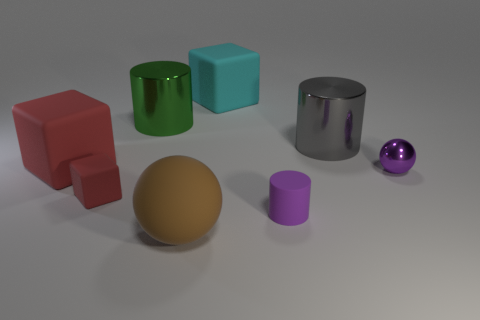Add 2 big gray cylinders. How many objects exist? 10 Subtract all balls. How many objects are left? 6 Add 5 balls. How many balls are left? 7 Add 3 large purple balls. How many large purple balls exist? 3 Subtract 1 green cylinders. How many objects are left? 7 Subtract all large cubes. Subtract all large brown objects. How many objects are left? 5 